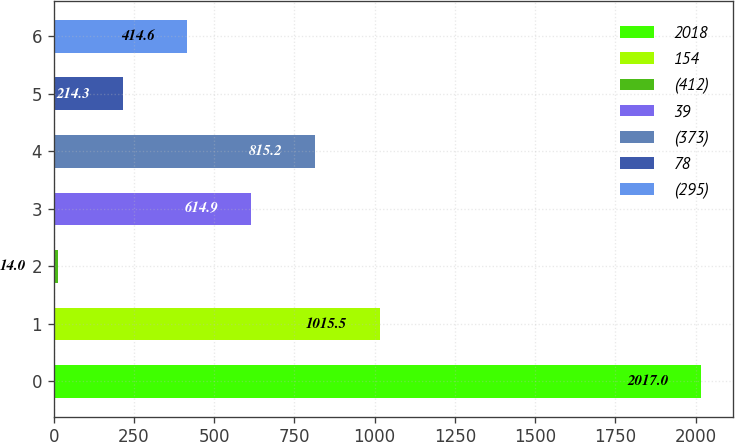<chart> <loc_0><loc_0><loc_500><loc_500><bar_chart><fcel>2018<fcel>154<fcel>(412)<fcel>39<fcel>(373)<fcel>78<fcel>(295)<nl><fcel>2017<fcel>1015.5<fcel>14<fcel>614.9<fcel>815.2<fcel>214.3<fcel>414.6<nl></chart> 